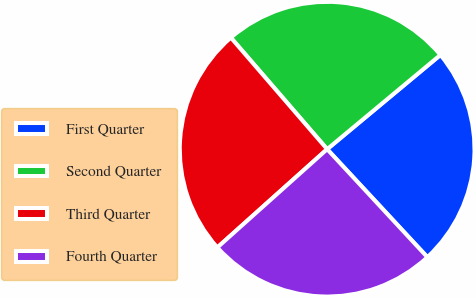Convert chart to OTSL. <chart><loc_0><loc_0><loc_500><loc_500><pie_chart><fcel>First Quarter<fcel>Second Quarter<fcel>Third Quarter<fcel>Fourth Quarter<nl><fcel>24.14%<fcel>25.29%<fcel>25.29%<fcel>25.29%<nl></chart> 